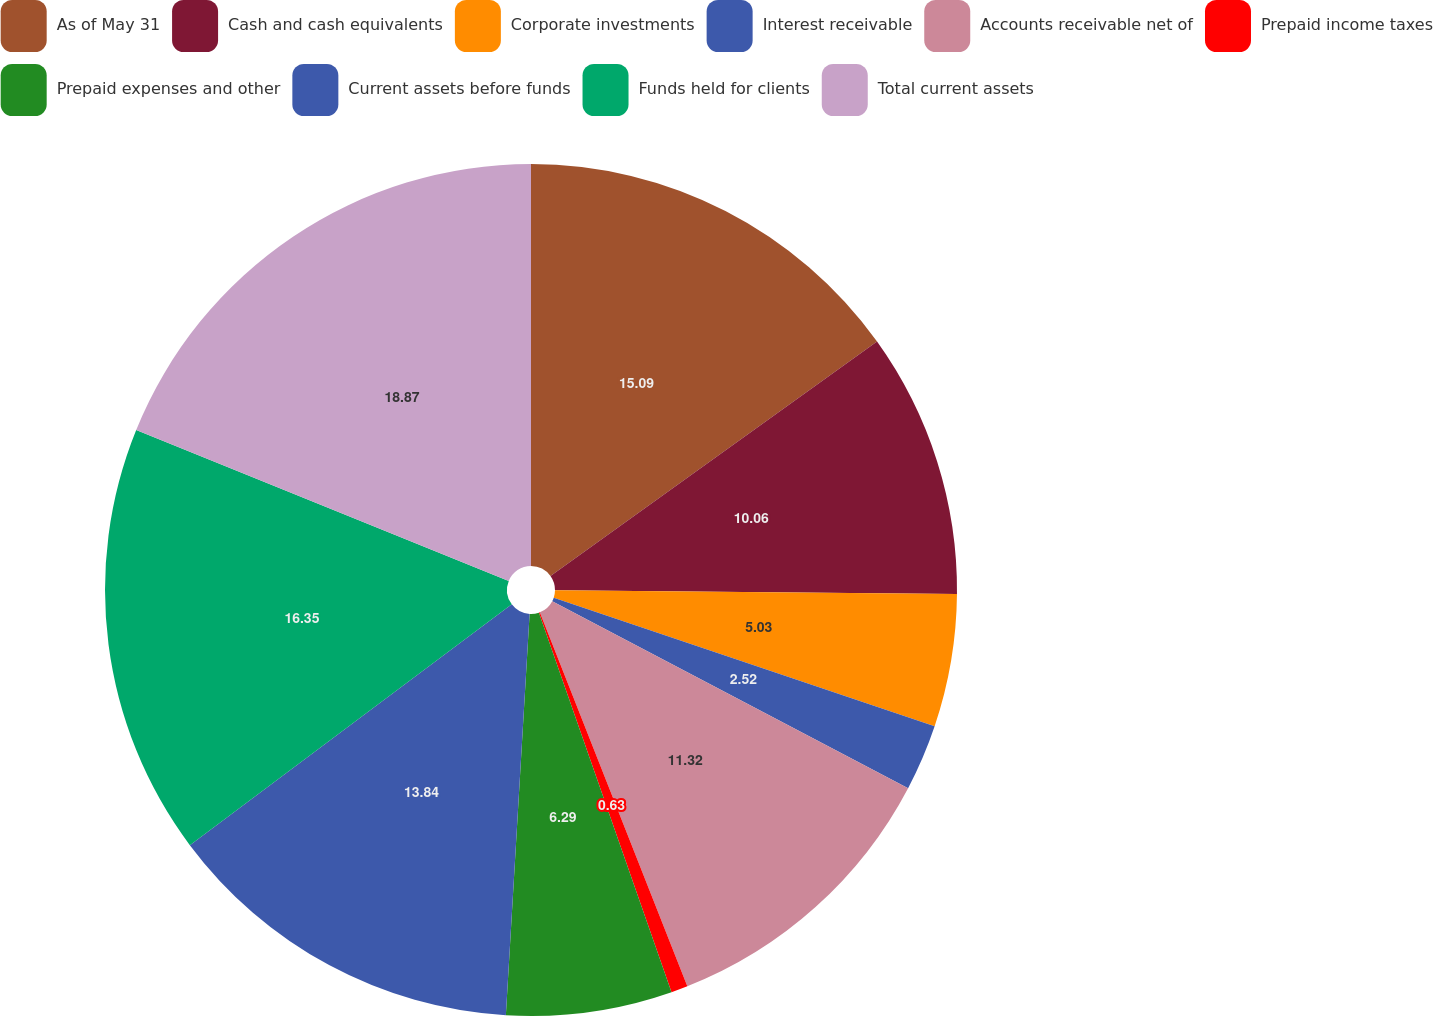<chart> <loc_0><loc_0><loc_500><loc_500><pie_chart><fcel>As of May 31<fcel>Cash and cash equivalents<fcel>Corporate investments<fcel>Interest receivable<fcel>Accounts receivable net of<fcel>Prepaid income taxes<fcel>Prepaid expenses and other<fcel>Current assets before funds<fcel>Funds held for clients<fcel>Total current assets<nl><fcel>15.09%<fcel>10.06%<fcel>5.03%<fcel>2.52%<fcel>11.32%<fcel>0.63%<fcel>6.29%<fcel>13.84%<fcel>16.35%<fcel>18.87%<nl></chart> 